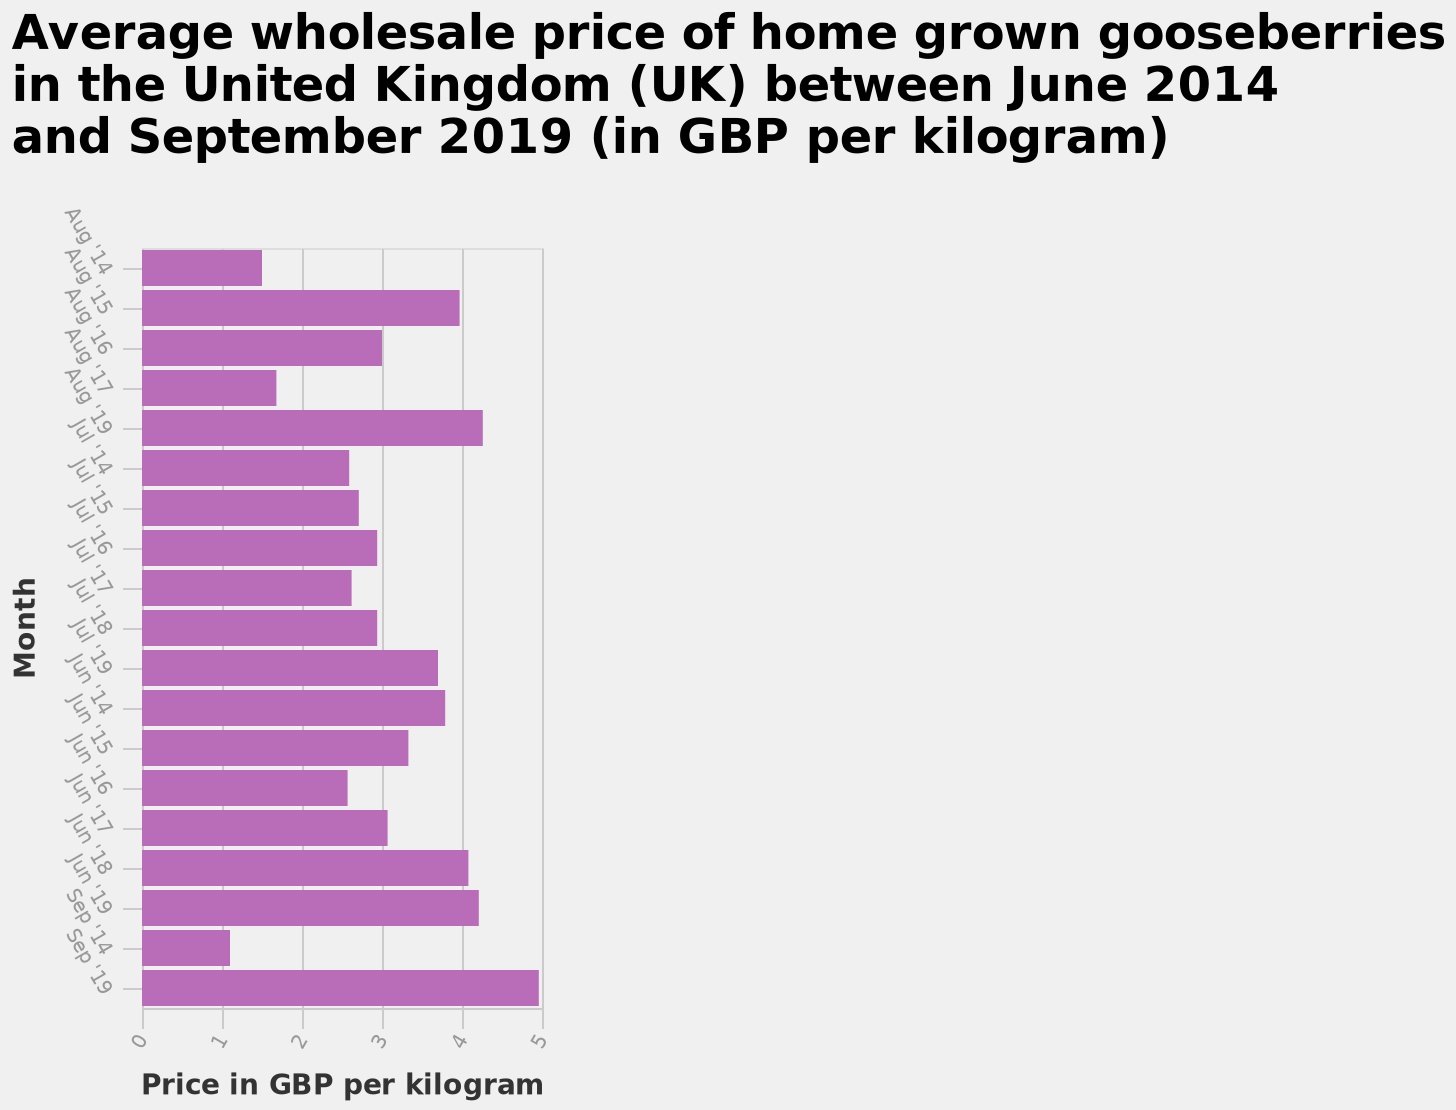<image>
What does the bar plot represent? The bar plot represents the average wholesale price of home grown gooseberries in the United Kingdom (UK) between June 2014 and September 2019 (in GBP per kilogram). During which month should gooseberries be collected? September. What is the x-axis labeled in the bar plot? The x-axis is labeled as "Price in GBP per kilogram". 